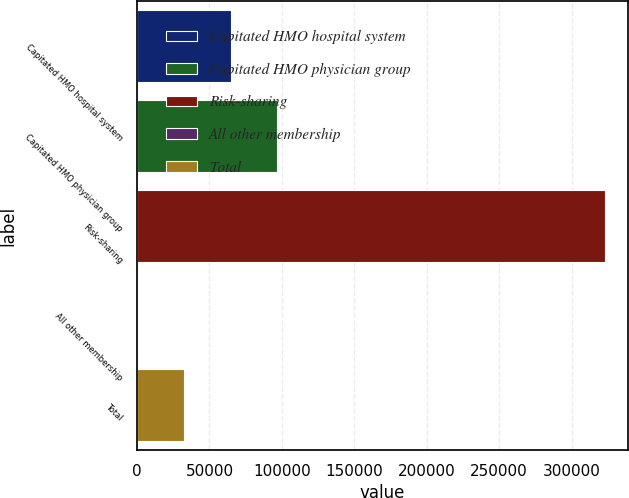Convert chart. <chart><loc_0><loc_0><loc_500><loc_500><bar_chart><fcel>Capitated HMO hospital system<fcel>Capitated HMO physician group<fcel>Risk-sharing<fcel>All other membership<fcel>Total<nl><fcel>64622.7<fcel>96894.9<fcel>322800<fcel>78.4<fcel>32350.6<nl></chart> 